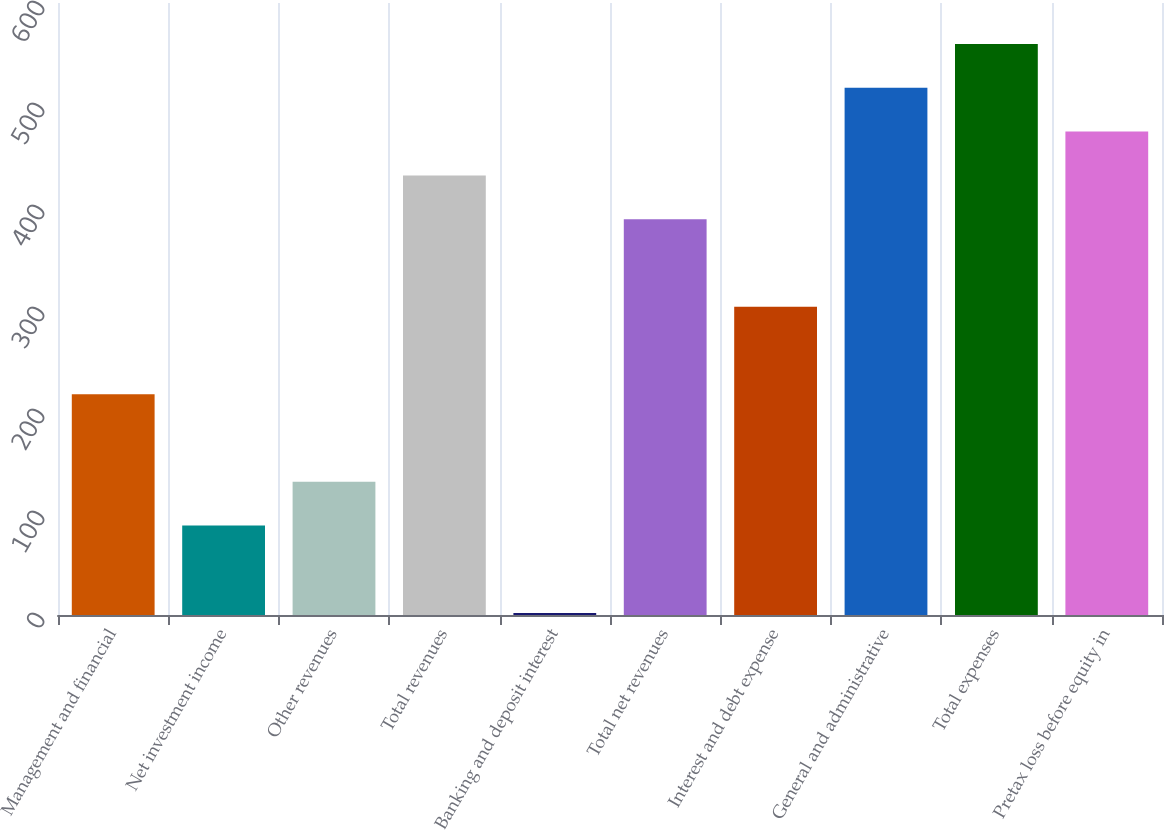Convert chart. <chart><loc_0><loc_0><loc_500><loc_500><bar_chart><fcel>Management and financial<fcel>Net investment income<fcel>Other revenues<fcel>Total revenues<fcel>Banking and deposit interest<fcel>Total net revenues<fcel>Interest and debt expense<fcel>General and administrative<fcel>Total expenses<fcel>Pretax loss before equity in<nl><fcel>216.5<fcel>87.8<fcel>130.7<fcel>431<fcel>2<fcel>388.1<fcel>302.3<fcel>516.8<fcel>559.7<fcel>473.9<nl></chart> 